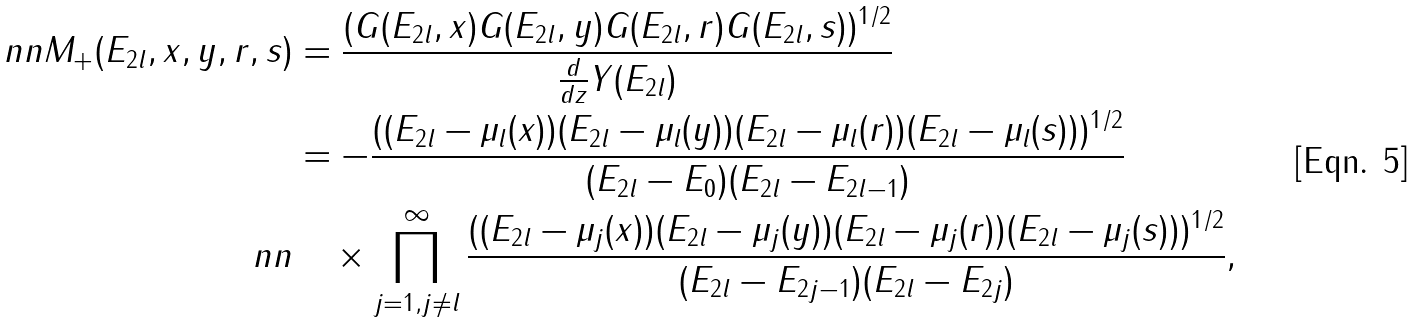Convert formula to latex. <formula><loc_0><loc_0><loc_500><loc_500>\ n n M _ { + } ( E _ { 2 l } , x , y , r , s ) & = \frac { ( G ( E _ { 2 l } , x ) G ( E _ { 2 l } , y ) G ( E _ { 2 l } , r ) G ( E _ { 2 l } , s ) ) ^ { 1 / 2 } } { \frac { d } { d z } Y ( E _ { 2 l } ) } \\ & = - \frac { ( ( E _ { 2 l } - \mu _ { l } ( x ) ) ( E _ { 2 l } - \mu _ { l } ( y ) ) ( E _ { 2 l } - \mu _ { l } ( r ) ) ( E _ { 2 l } - \mu _ { l } ( s ) ) ) ^ { 1 / 2 } } { ( E _ { 2 l } - E _ { 0 } ) ( E _ { 2 l } - E _ { 2 l - 1 } ) } \\ \ n n & \quad \times \prod _ { j = 1 , j \not = l } ^ { \infty } \frac { ( ( E _ { 2 l } - \mu _ { j } ( x ) ) ( E _ { 2 l } - \mu _ { j } ( y ) ) ( E _ { 2 l } - \mu _ { j } ( r ) ) ( E _ { 2 l } - \mu _ { j } ( s ) ) ) ^ { 1 / 2 } } { ( E _ { 2 l } - E _ { 2 j - 1 } ) ( E _ { 2 l } - E _ { 2 j } ) } ,</formula> 